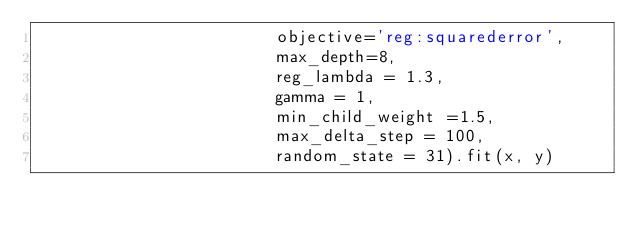<code> <loc_0><loc_0><loc_500><loc_500><_Python_>                        objective='reg:squarederror', 
                        max_depth=8, 
                        reg_lambda = 1.3,
                        gamma = 1,
                        min_child_weight =1.5,
                        max_delta_step = 100,
                        random_state = 31).fit(x, y)
</code> 